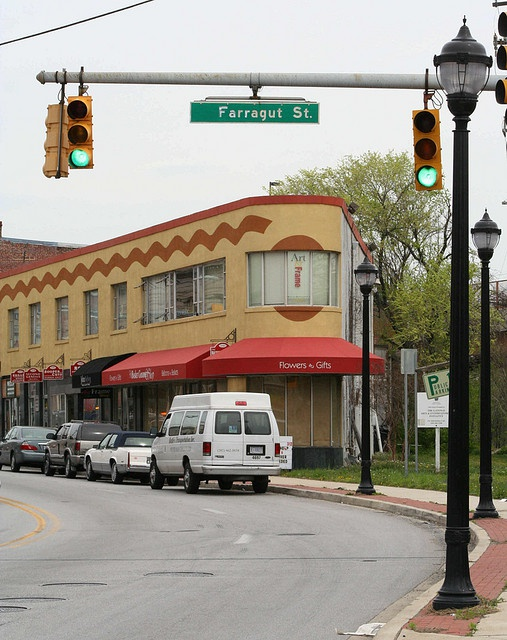Describe the objects in this image and their specific colors. I can see truck in white, darkgray, lightgray, gray, and black tones, car in white, black, gray, darkgray, and lightgray tones, truck in white, gray, black, and darkgray tones, car in white, gray, black, and darkgray tones, and traffic light in white, black, brown, maroon, and ivory tones in this image. 